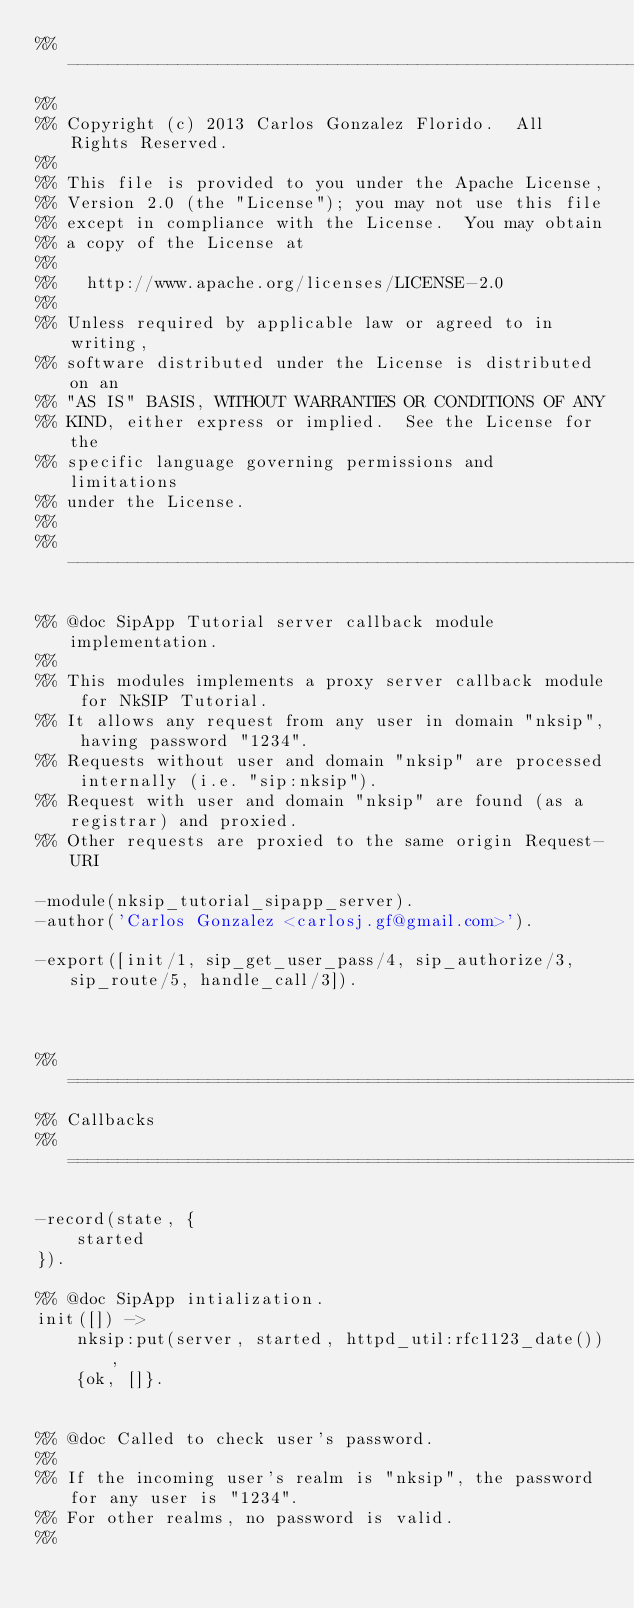Convert code to text. <code><loc_0><loc_0><loc_500><loc_500><_Erlang_>%% -------------------------------------------------------------------
%%
%% Copyright (c) 2013 Carlos Gonzalez Florido.  All Rights Reserved.
%%
%% This file is provided to you under the Apache License,
%% Version 2.0 (the "License"); you may not use this file
%% except in compliance with the License.  You may obtain
%% a copy of the License at
%%
%%   http://www.apache.org/licenses/LICENSE-2.0
%%
%% Unless required by applicable law or agreed to in writing,
%% software distributed under the License is distributed on an
%% "AS IS" BASIS, WITHOUT WARRANTIES OR CONDITIONS OF ANY
%% KIND, either express or implied.  See the License for the
%% specific language governing permissions and limitations
%% under the License.
%%
%% -------------------------------------------------------------------

%% @doc SipApp Tutorial server callback module implementation.
%%
%% This modules implements a proxy server callback module for NkSIP Tutorial.
%% It allows any request from any user in domain "nksip", having password "1234".
%% Requests without user and domain "nksip" are processed internally (i.e. "sip:nksip").
%% Request with user and domain "nksip" are found (as a registrar) and proxied.
%% Other requests are proxied to the same origin Request-URI

-module(nksip_tutorial_sipapp_server).
-author('Carlos Gonzalez <carlosj.gf@gmail.com>').

-export([init/1, sip_get_user_pass/4, sip_authorize/3, sip_route/5, handle_call/3]).



%% ===================================================================
%% Callbacks
%% ===================================================================

-record(state, {
    started
}).

%% @doc SipApp intialization.
init([]) ->
    nksip:put(server, started, httpd_util:rfc1123_date()),
    {ok, []}.


%% @doc Called to check user's password.
%%
%% If the incoming user's realm is "nksip", the password for any user is "1234". 
%% For other realms, no password is valid.
%%</code> 